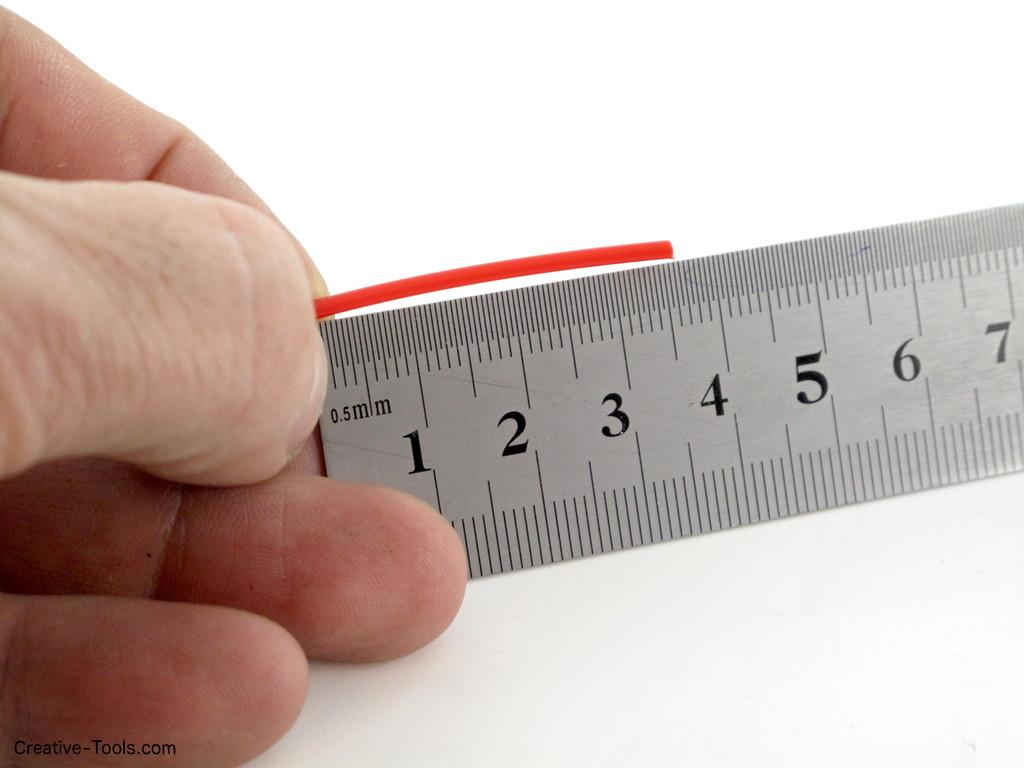<image>
Give a short and clear explanation of the subsequent image. The red piece is a little over 3.5 centimeters, according to the ruler. 